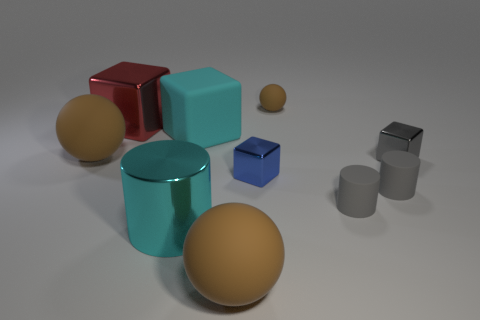How many cyan metal objects have the same size as the red metallic thing?
Provide a succinct answer. 1. The rubber block that is the same color as the large shiny cylinder is what size?
Provide a short and direct response. Large. Are there any other cubes that have the same color as the large rubber cube?
Keep it short and to the point. No. The metallic cube that is the same size as the blue object is what color?
Make the answer very short. Gray. Do the tiny ball and the rubber sphere that is left of the big metallic cube have the same color?
Your answer should be compact. Yes. The large rubber cube is what color?
Ensure brevity in your answer.  Cyan. What material is the brown object in front of the tiny gray metal cube?
Offer a very short reply. Rubber. There is a blue object that is the same shape as the red object; what size is it?
Provide a succinct answer. Small. Is the number of blocks to the right of the gray metallic block less than the number of shiny things?
Your answer should be compact. Yes. Are there any small blue shiny things?
Your answer should be compact. Yes. 